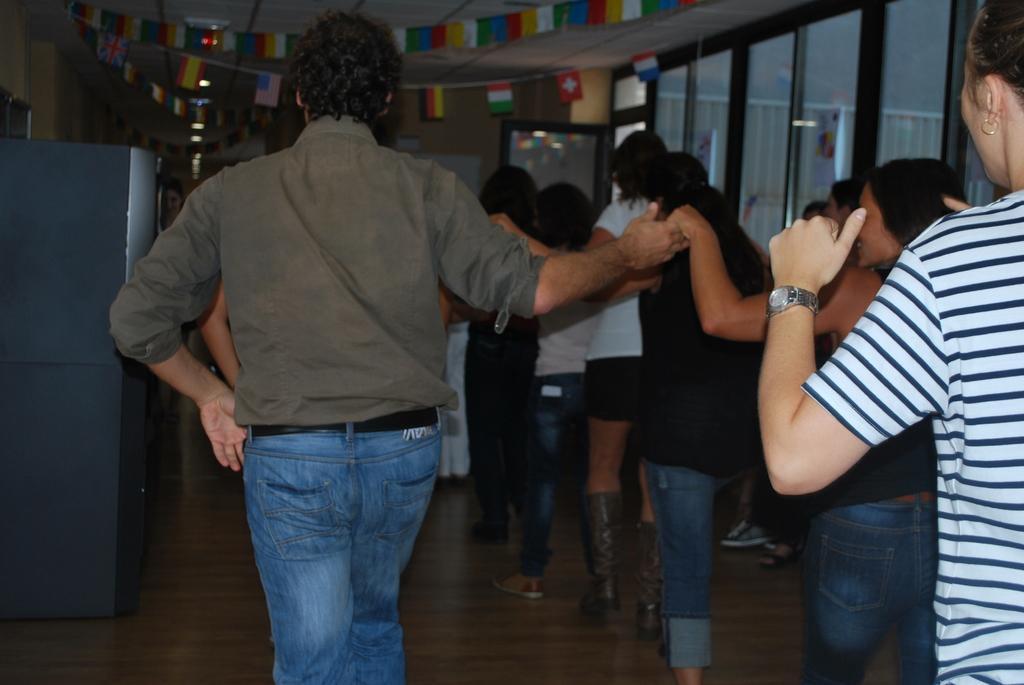How would you summarize this image in a sentence or two? In the middle of the image few people are standing and holding hands. In front of them we can see wall and some objects, on the wall we can see a board. In the top right corner of the image we can see a glass wall. At the top of the image we can see ceiling, lights and banners. 